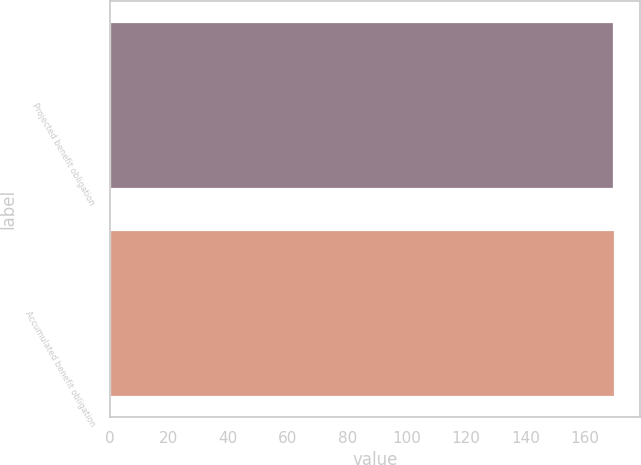Convert chart. <chart><loc_0><loc_0><loc_500><loc_500><bar_chart><fcel>Projected benefit obligation<fcel>Accumulated benefit obligation<nl><fcel>170<fcel>170.1<nl></chart> 